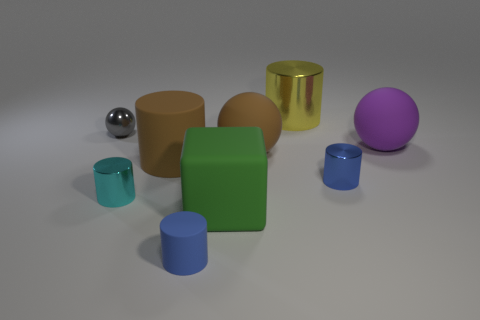Subtract all cyan cylinders. How many cylinders are left? 4 Subtract all cyan cylinders. How many cylinders are left? 4 Subtract all brown cylinders. Subtract all cyan spheres. How many cylinders are left? 4 Add 1 brown spheres. How many objects exist? 10 Subtract all spheres. How many objects are left? 6 Add 1 big purple rubber balls. How many big purple rubber balls exist? 2 Subtract 0 yellow blocks. How many objects are left? 9 Subtract all cyan metal cylinders. Subtract all large rubber balls. How many objects are left? 6 Add 1 purple spheres. How many purple spheres are left? 2 